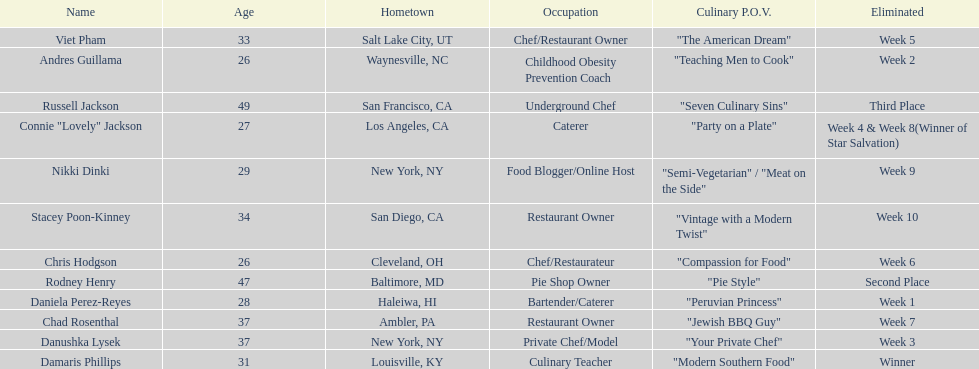Which contestant's culinary point of view had a longer description than "vintage with a modern twist"? Nikki Dinki. 